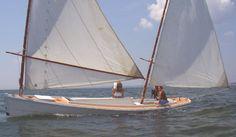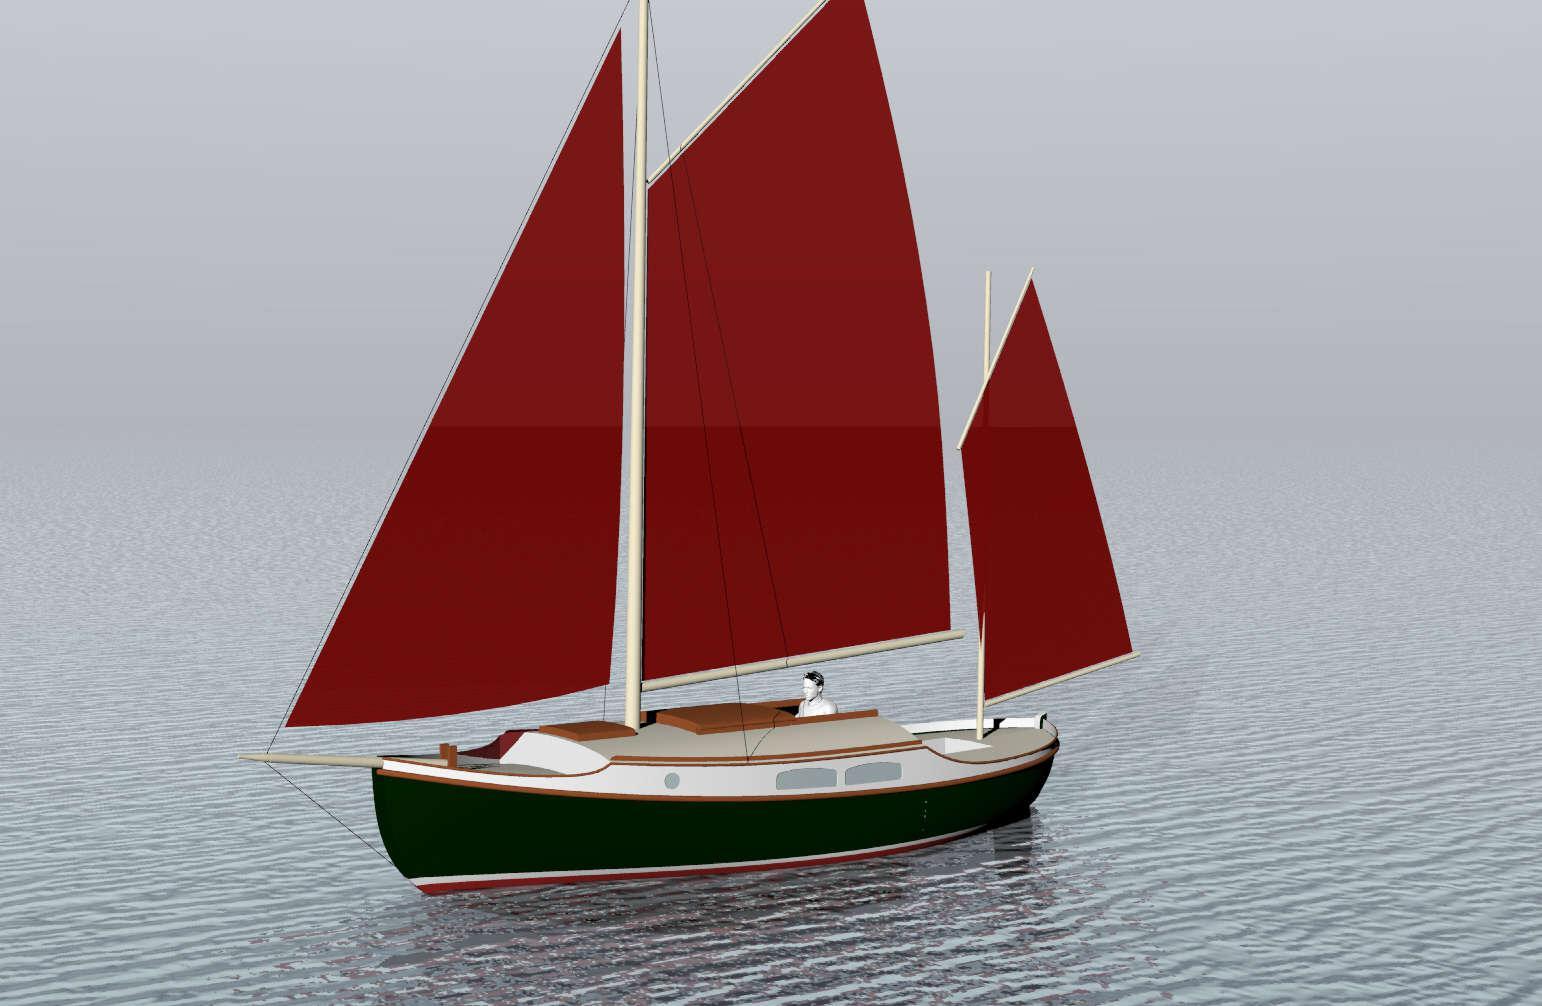The first image is the image on the left, the second image is the image on the right. Evaluate the accuracy of this statement regarding the images: "Each sailboat has two white sails.". Is it true? Answer yes or no. No. 